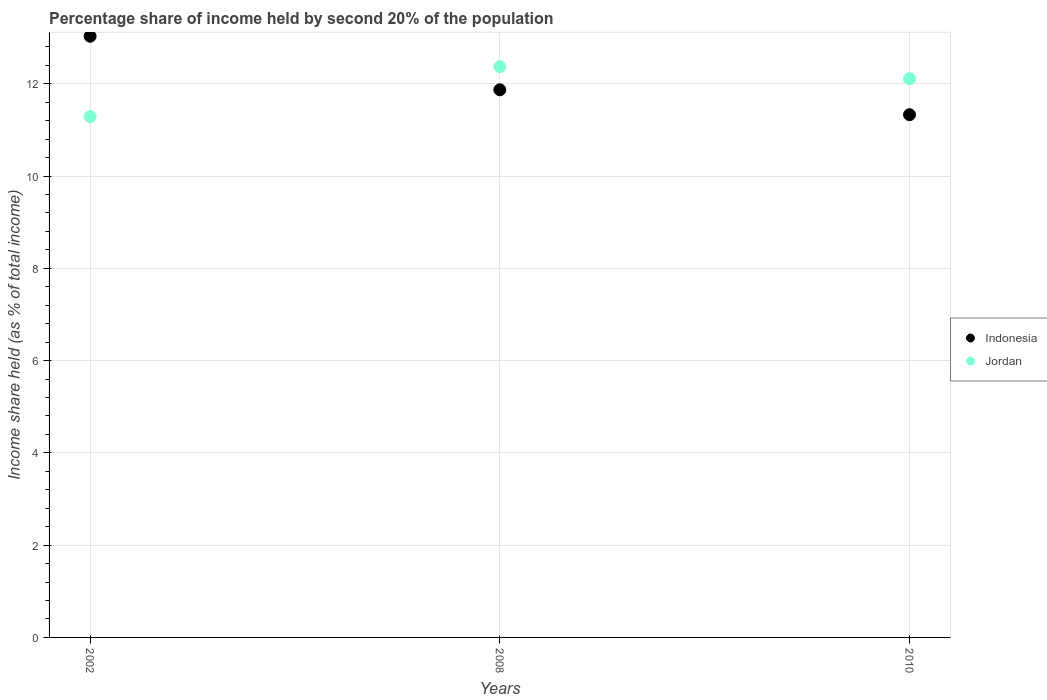Is the number of dotlines equal to the number of legend labels?
Ensure brevity in your answer.  Yes. What is the share of income held by second 20% of the population in Jordan in 2010?
Offer a very short reply. 12.11. Across all years, what is the maximum share of income held by second 20% of the population in Jordan?
Offer a terse response. 12.37. Across all years, what is the minimum share of income held by second 20% of the population in Jordan?
Offer a terse response. 11.29. In which year was the share of income held by second 20% of the population in Indonesia maximum?
Provide a short and direct response. 2002. In which year was the share of income held by second 20% of the population in Indonesia minimum?
Offer a terse response. 2010. What is the total share of income held by second 20% of the population in Jordan in the graph?
Provide a short and direct response. 35.77. What is the difference between the share of income held by second 20% of the population in Jordan in 2008 and that in 2010?
Ensure brevity in your answer.  0.26. What is the difference between the share of income held by second 20% of the population in Jordan in 2002 and the share of income held by second 20% of the population in Indonesia in 2010?
Offer a terse response. -0.04. What is the average share of income held by second 20% of the population in Indonesia per year?
Provide a short and direct response. 12.08. In the year 2002, what is the difference between the share of income held by second 20% of the population in Jordan and share of income held by second 20% of the population in Indonesia?
Your answer should be very brief. -1.74. In how many years, is the share of income held by second 20% of the population in Jordan greater than 2.4 %?
Provide a succinct answer. 3. What is the ratio of the share of income held by second 20% of the population in Jordan in 2002 to that in 2010?
Your answer should be very brief. 0.93. What is the difference between the highest and the second highest share of income held by second 20% of the population in Jordan?
Provide a succinct answer. 0.26. What is the difference between the highest and the lowest share of income held by second 20% of the population in Jordan?
Offer a very short reply. 1.08. In how many years, is the share of income held by second 20% of the population in Jordan greater than the average share of income held by second 20% of the population in Jordan taken over all years?
Your answer should be very brief. 2. Is the sum of the share of income held by second 20% of the population in Jordan in 2002 and 2010 greater than the maximum share of income held by second 20% of the population in Indonesia across all years?
Your response must be concise. Yes. Is the share of income held by second 20% of the population in Indonesia strictly greater than the share of income held by second 20% of the population in Jordan over the years?
Your response must be concise. No. Is the share of income held by second 20% of the population in Indonesia strictly less than the share of income held by second 20% of the population in Jordan over the years?
Give a very brief answer. No. How many years are there in the graph?
Offer a terse response. 3. What is the difference between two consecutive major ticks on the Y-axis?
Offer a terse response. 2. Does the graph contain any zero values?
Offer a very short reply. No. Does the graph contain grids?
Your answer should be very brief. Yes. How many legend labels are there?
Make the answer very short. 2. How are the legend labels stacked?
Keep it short and to the point. Vertical. What is the title of the graph?
Your answer should be compact. Percentage share of income held by second 20% of the population. Does "Latin America(all income levels)" appear as one of the legend labels in the graph?
Your answer should be very brief. No. What is the label or title of the X-axis?
Ensure brevity in your answer.  Years. What is the label or title of the Y-axis?
Make the answer very short. Income share held (as % of total income). What is the Income share held (as % of total income) in Indonesia in 2002?
Keep it short and to the point. 13.03. What is the Income share held (as % of total income) of Jordan in 2002?
Offer a terse response. 11.29. What is the Income share held (as % of total income) of Indonesia in 2008?
Offer a terse response. 11.87. What is the Income share held (as % of total income) of Jordan in 2008?
Provide a short and direct response. 12.37. What is the Income share held (as % of total income) in Indonesia in 2010?
Your response must be concise. 11.33. What is the Income share held (as % of total income) of Jordan in 2010?
Provide a succinct answer. 12.11. Across all years, what is the maximum Income share held (as % of total income) in Indonesia?
Keep it short and to the point. 13.03. Across all years, what is the maximum Income share held (as % of total income) of Jordan?
Ensure brevity in your answer.  12.37. Across all years, what is the minimum Income share held (as % of total income) of Indonesia?
Your answer should be compact. 11.33. Across all years, what is the minimum Income share held (as % of total income) of Jordan?
Offer a very short reply. 11.29. What is the total Income share held (as % of total income) in Indonesia in the graph?
Make the answer very short. 36.23. What is the total Income share held (as % of total income) in Jordan in the graph?
Provide a succinct answer. 35.77. What is the difference between the Income share held (as % of total income) of Indonesia in 2002 and that in 2008?
Your response must be concise. 1.16. What is the difference between the Income share held (as % of total income) of Jordan in 2002 and that in 2008?
Your answer should be compact. -1.08. What is the difference between the Income share held (as % of total income) of Jordan in 2002 and that in 2010?
Provide a succinct answer. -0.82. What is the difference between the Income share held (as % of total income) of Indonesia in 2008 and that in 2010?
Offer a very short reply. 0.54. What is the difference between the Income share held (as % of total income) in Jordan in 2008 and that in 2010?
Ensure brevity in your answer.  0.26. What is the difference between the Income share held (as % of total income) in Indonesia in 2002 and the Income share held (as % of total income) in Jordan in 2008?
Offer a very short reply. 0.66. What is the difference between the Income share held (as % of total income) in Indonesia in 2008 and the Income share held (as % of total income) in Jordan in 2010?
Ensure brevity in your answer.  -0.24. What is the average Income share held (as % of total income) of Indonesia per year?
Keep it short and to the point. 12.08. What is the average Income share held (as % of total income) of Jordan per year?
Offer a very short reply. 11.92. In the year 2002, what is the difference between the Income share held (as % of total income) in Indonesia and Income share held (as % of total income) in Jordan?
Ensure brevity in your answer.  1.74. In the year 2010, what is the difference between the Income share held (as % of total income) of Indonesia and Income share held (as % of total income) of Jordan?
Your answer should be compact. -0.78. What is the ratio of the Income share held (as % of total income) in Indonesia in 2002 to that in 2008?
Your response must be concise. 1.1. What is the ratio of the Income share held (as % of total income) of Jordan in 2002 to that in 2008?
Offer a very short reply. 0.91. What is the ratio of the Income share held (as % of total income) of Indonesia in 2002 to that in 2010?
Keep it short and to the point. 1.15. What is the ratio of the Income share held (as % of total income) in Jordan in 2002 to that in 2010?
Provide a succinct answer. 0.93. What is the ratio of the Income share held (as % of total income) in Indonesia in 2008 to that in 2010?
Offer a terse response. 1.05. What is the ratio of the Income share held (as % of total income) in Jordan in 2008 to that in 2010?
Provide a succinct answer. 1.02. What is the difference between the highest and the second highest Income share held (as % of total income) of Indonesia?
Your answer should be compact. 1.16. What is the difference between the highest and the second highest Income share held (as % of total income) of Jordan?
Make the answer very short. 0.26. What is the difference between the highest and the lowest Income share held (as % of total income) in Indonesia?
Offer a very short reply. 1.7. What is the difference between the highest and the lowest Income share held (as % of total income) in Jordan?
Keep it short and to the point. 1.08. 